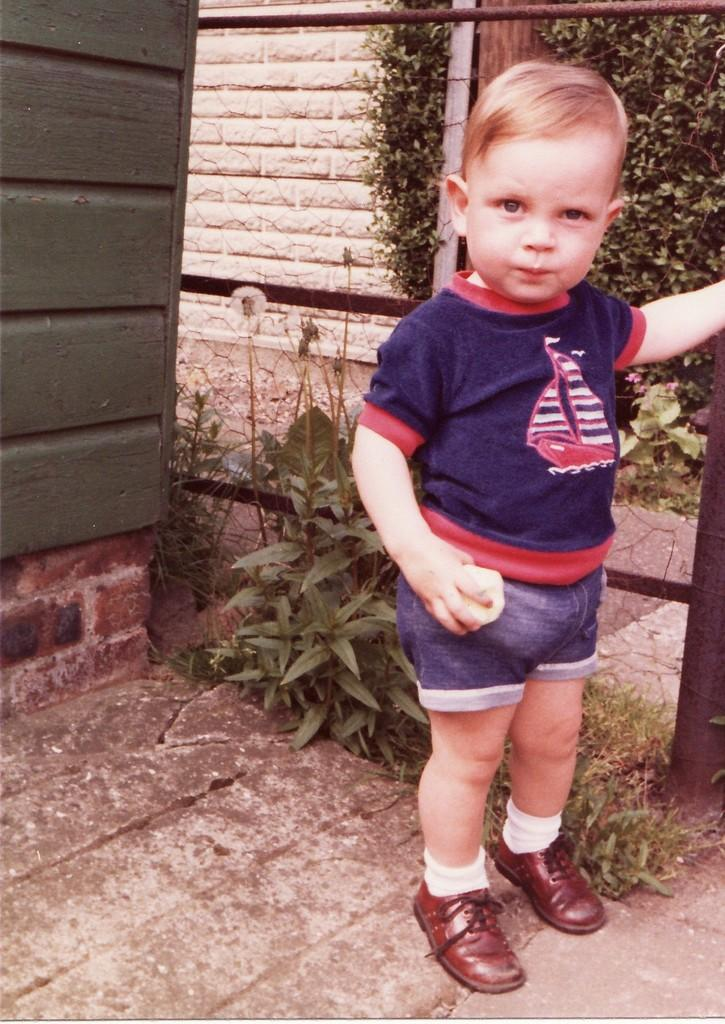What is the main subject of the image? There is a child standing in the image. Can you describe the child's attire? The child is wearing clothes, socks, and shoes. What type of terrain is visible in the image? There is grass visible in the image. What other objects can be seen in the image? There is a plant and a wall in the image. What type of notebook is the child using to help the bell ring in the image? There is no notebook, bell, or any activity involving a bell in the image. 